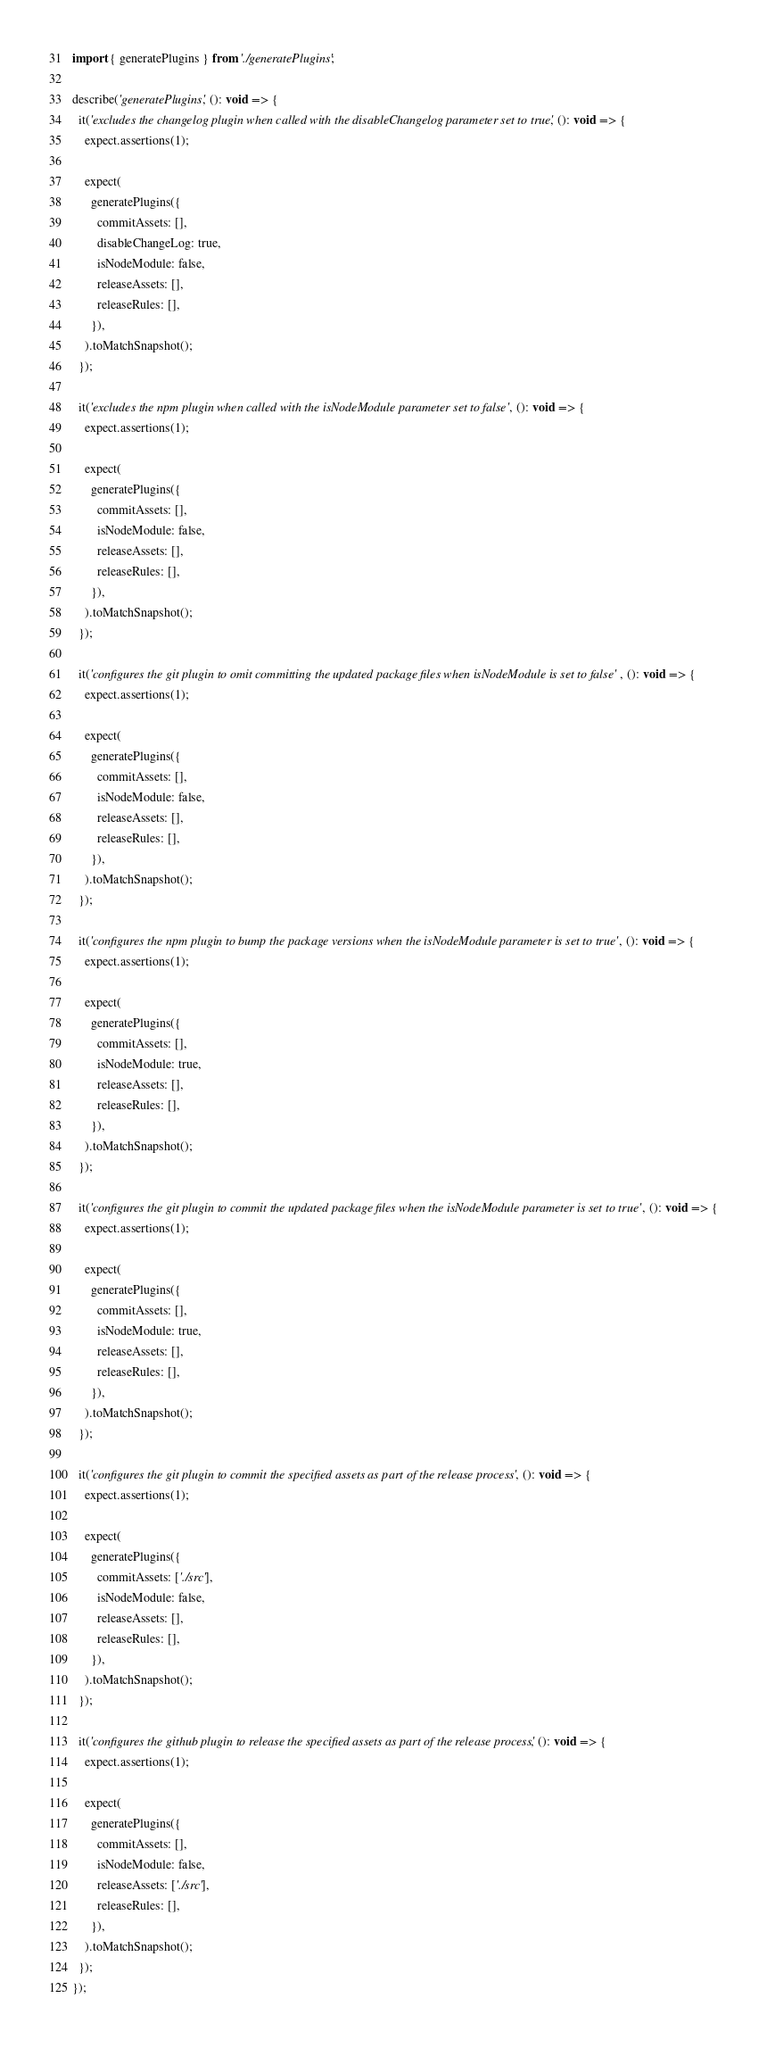<code> <loc_0><loc_0><loc_500><loc_500><_TypeScript_>import { generatePlugins } from './generatePlugins';

describe('generatePlugins', (): void => {
  it('excludes the changelog plugin when called with the disableChangelog parameter set to true', (): void => {
    expect.assertions(1);

    expect(
      generatePlugins({
        commitAssets: [],
        disableChangeLog: true,
        isNodeModule: false,
        releaseAssets: [],
        releaseRules: [],
      }),
    ).toMatchSnapshot();
  });

  it('excludes the npm plugin when called with the isNodeModule parameter set to false', (): void => {
    expect.assertions(1);

    expect(
      generatePlugins({
        commitAssets: [],
        isNodeModule: false,
        releaseAssets: [],
        releaseRules: [],
      }),
    ).toMatchSnapshot();
  });

  it('configures the git plugin to omit committing the updated package files when isNodeModule is set to false', (): void => {
    expect.assertions(1);

    expect(
      generatePlugins({
        commitAssets: [],
        isNodeModule: false,
        releaseAssets: [],
        releaseRules: [],
      }),
    ).toMatchSnapshot();
  });

  it('configures the npm plugin to bump the package versions when the isNodeModule parameter is set to true', (): void => {
    expect.assertions(1);

    expect(
      generatePlugins({
        commitAssets: [],
        isNodeModule: true,
        releaseAssets: [],
        releaseRules: [],
      }),
    ).toMatchSnapshot();
  });

  it('configures the git plugin to commit the updated package files when the isNodeModule parameter is set to true', (): void => {
    expect.assertions(1);

    expect(
      generatePlugins({
        commitAssets: [],
        isNodeModule: true,
        releaseAssets: [],
        releaseRules: [],
      }),
    ).toMatchSnapshot();
  });

  it('configures the git plugin to commit the specified assets as part of the release process', (): void => {
    expect.assertions(1);

    expect(
      generatePlugins({
        commitAssets: ['./src'],
        isNodeModule: false,
        releaseAssets: [],
        releaseRules: [],
      }),
    ).toMatchSnapshot();
  });

  it('configures the github plugin to release the specified assets as part of the release process', (): void => {
    expect.assertions(1);

    expect(
      generatePlugins({
        commitAssets: [],
        isNodeModule: false,
        releaseAssets: ['./src'],
        releaseRules: [],
      }),
    ).toMatchSnapshot();
  });
});
</code> 